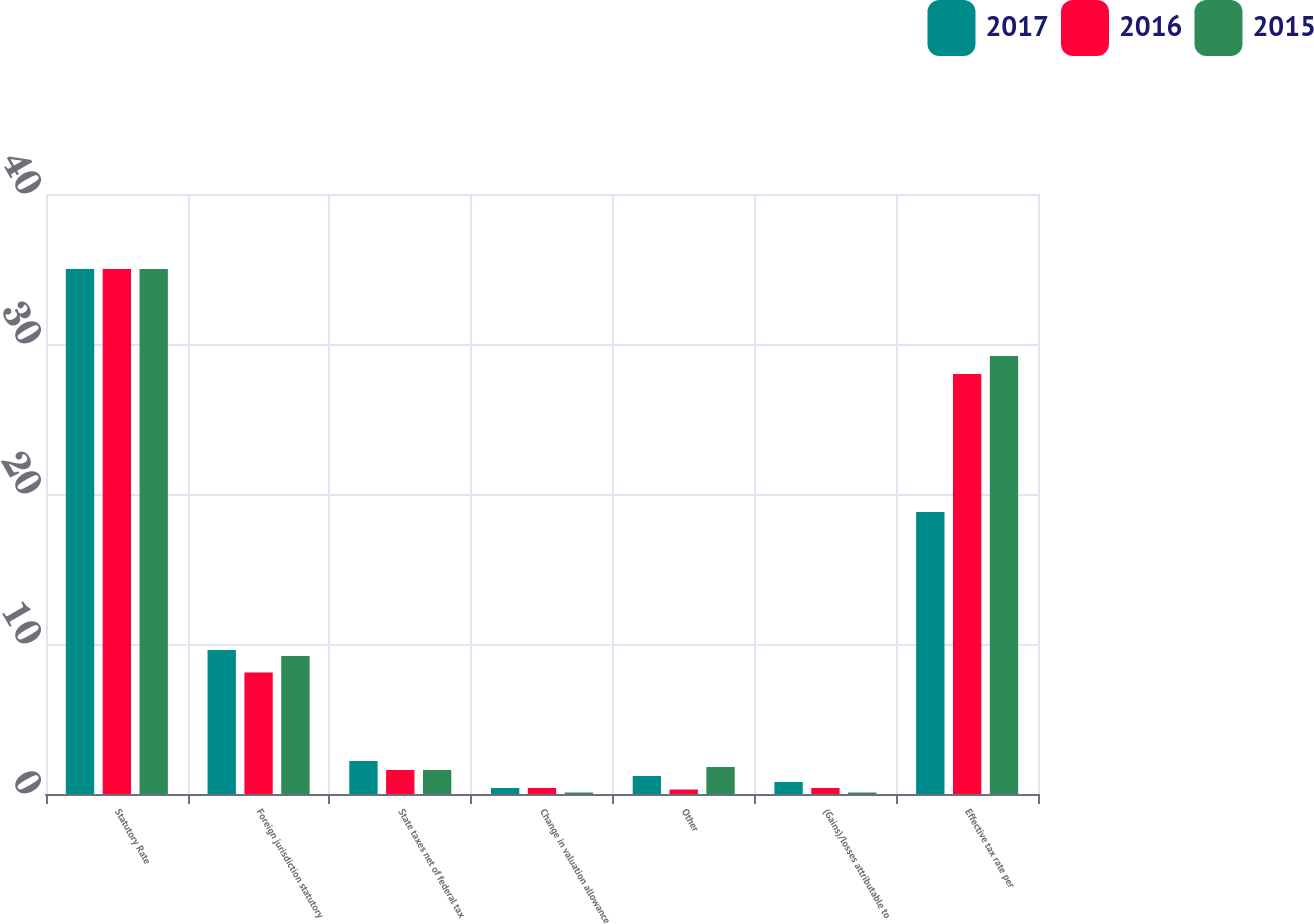<chart> <loc_0><loc_0><loc_500><loc_500><stacked_bar_chart><ecel><fcel>Statutory Rate<fcel>Foreign jurisdiction statutory<fcel>State taxes net of federal tax<fcel>Change in valuation allowance<fcel>Other<fcel>(Gains)/losses attributable to<fcel>Effective tax rate per<nl><fcel>2017<fcel>35<fcel>9.6<fcel>2.2<fcel>0.4<fcel>1.2<fcel>0.8<fcel>18.8<nl><fcel>2016<fcel>35<fcel>8.1<fcel>1.6<fcel>0.4<fcel>0.3<fcel>0.4<fcel>28<nl><fcel>2015<fcel>35<fcel>9.2<fcel>1.6<fcel>0.1<fcel>1.8<fcel>0.1<fcel>29.2<nl></chart> 